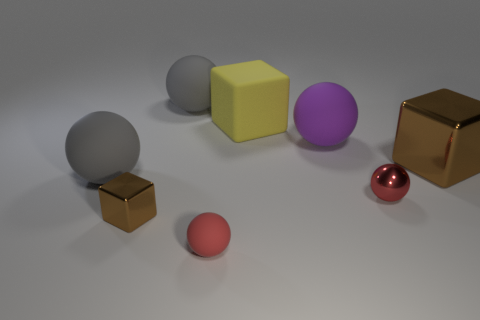There is a purple object that is the same size as the yellow block; what material is it?
Your answer should be compact. Rubber. Are there more red matte things to the right of the big yellow block than purple spheres that are in front of the big purple object?
Your answer should be compact. No. Is there another brown thing of the same shape as the large brown object?
Provide a short and direct response. Yes. There is another red object that is the same size as the red rubber object; what is its shape?
Give a very brief answer. Sphere. The gray thing that is right of the small brown cube has what shape?
Give a very brief answer. Sphere. Is the number of small rubber things right of the red metal thing less than the number of large purple rubber spheres in front of the tiny matte sphere?
Make the answer very short. No. Is the size of the metal ball the same as the brown object to the right of the metallic ball?
Your answer should be compact. No. What number of purple shiny cubes are the same size as the yellow rubber object?
Your answer should be very brief. 0. There is another block that is the same material as the big brown block; what is its color?
Offer a very short reply. Brown. Are there more purple objects than big objects?
Keep it short and to the point. No. 